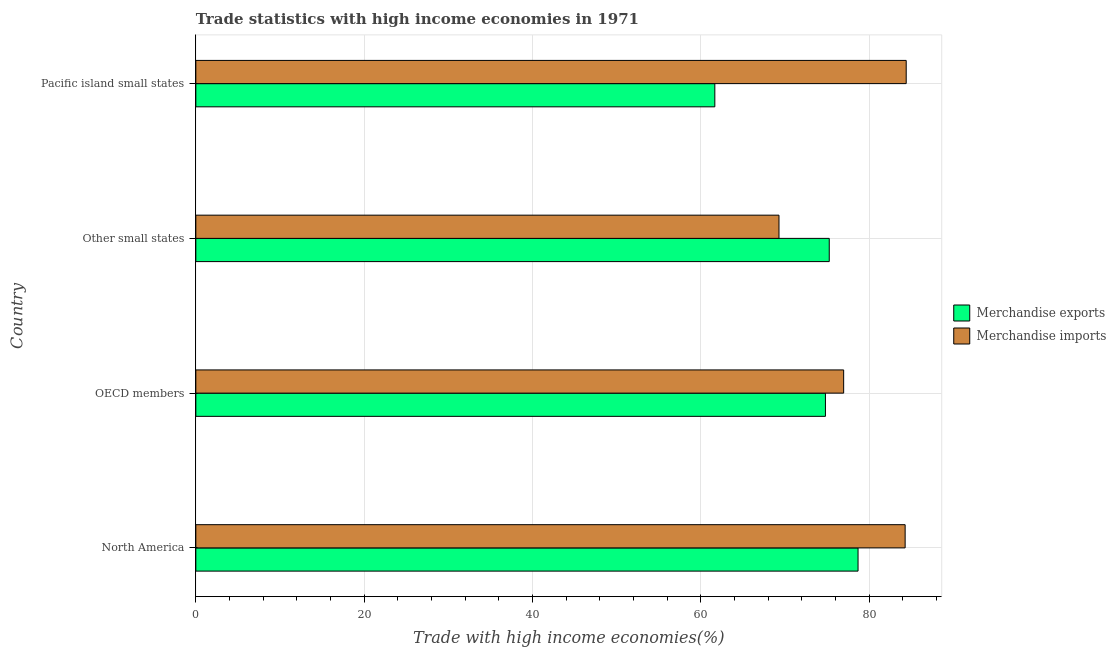How many groups of bars are there?
Provide a short and direct response. 4. Are the number of bars per tick equal to the number of legend labels?
Offer a terse response. Yes. What is the label of the 3rd group of bars from the top?
Make the answer very short. OECD members. What is the merchandise exports in OECD members?
Provide a succinct answer. 74.82. Across all countries, what is the maximum merchandise imports?
Provide a short and direct response. 84.42. Across all countries, what is the minimum merchandise exports?
Make the answer very short. 61.68. In which country was the merchandise imports maximum?
Make the answer very short. Pacific island small states. In which country was the merchandise exports minimum?
Your answer should be very brief. Pacific island small states. What is the total merchandise imports in the graph?
Your answer should be compact. 315. What is the difference between the merchandise imports in North America and that in Pacific island small states?
Give a very brief answer. -0.13. What is the difference between the merchandise exports in Pacific island small states and the merchandise imports in Other small states?
Give a very brief answer. -7.62. What is the average merchandise exports per country?
Your answer should be very brief. 72.62. What is the difference between the merchandise imports and merchandise exports in Pacific island small states?
Provide a short and direct response. 22.74. What is the ratio of the merchandise exports in North America to that in Pacific island small states?
Keep it short and to the point. 1.28. Is the merchandise imports in North America less than that in Other small states?
Keep it short and to the point. No. What is the difference between the highest and the second highest merchandise imports?
Ensure brevity in your answer.  0.13. What is the difference between the highest and the lowest merchandise imports?
Your answer should be very brief. 15.12. What is the difference between two consecutive major ticks on the X-axis?
Make the answer very short. 20. Are the values on the major ticks of X-axis written in scientific E-notation?
Offer a terse response. No. Does the graph contain any zero values?
Your response must be concise. No. What is the title of the graph?
Your answer should be compact. Trade statistics with high income economies in 1971. What is the label or title of the X-axis?
Make the answer very short. Trade with high income economies(%). What is the Trade with high income economies(%) in Merchandise exports in North America?
Keep it short and to the point. 78.7. What is the Trade with high income economies(%) in Merchandise imports in North America?
Give a very brief answer. 84.29. What is the Trade with high income economies(%) of Merchandise exports in OECD members?
Provide a short and direct response. 74.82. What is the Trade with high income economies(%) of Merchandise imports in OECD members?
Ensure brevity in your answer.  76.99. What is the Trade with high income economies(%) of Merchandise exports in Other small states?
Your answer should be very brief. 75.28. What is the Trade with high income economies(%) in Merchandise imports in Other small states?
Your answer should be very brief. 69.3. What is the Trade with high income economies(%) in Merchandise exports in Pacific island small states?
Your response must be concise. 61.68. What is the Trade with high income economies(%) in Merchandise imports in Pacific island small states?
Offer a very short reply. 84.42. Across all countries, what is the maximum Trade with high income economies(%) of Merchandise exports?
Ensure brevity in your answer.  78.7. Across all countries, what is the maximum Trade with high income economies(%) of Merchandise imports?
Provide a succinct answer. 84.42. Across all countries, what is the minimum Trade with high income economies(%) in Merchandise exports?
Keep it short and to the point. 61.68. Across all countries, what is the minimum Trade with high income economies(%) of Merchandise imports?
Keep it short and to the point. 69.3. What is the total Trade with high income economies(%) of Merchandise exports in the graph?
Give a very brief answer. 290.47. What is the total Trade with high income economies(%) in Merchandise imports in the graph?
Provide a short and direct response. 315. What is the difference between the Trade with high income economies(%) in Merchandise exports in North America and that in OECD members?
Keep it short and to the point. 3.88. What is the difference between the Trade with high income economies(%) of Merchandise imports in North America and that in OECD members?
Keep it short and to the point. 7.31. What is the difference between the Trade with high income economies(%) in Merchandise exports in North America and that in Other small states?
Keep it short and to the point. 3.42. What is the difference between the Trade with high income economies(%) of Merchandise imports in North America and that in Other small states?
Provide a short and direct response. 14.99. What is the difference between the Trade with high income economies(%) in Merchandise exports in North America and that in Pacific island small states?
Offer a very short reply. 17.02. What is the difference between the Trade with high income economies(%) in Merchandise imports in North America and that in Pacific island small states?
Your answer should be compact. -0.13. What is the difference between the Trade with high income economies(%) of Merchandise exports in OECD members and that in Other small states?
Make the answer very short. -0.45. What is the difference between the Trade with high income economies(%) of Merchandise imports in OECD members and that in Other small states?
Make the answer very short. 7.69. What is the difference between the Trade with high income economies(%) in Merchandise exports in OECD members and that in Pacific island small states?
Your answer should be compact. 13.14. What is the difference between the Trade with high income economies(%) of Merchandise imports in OECD members and that in Pacific island small states?
Give a very brief answer. -7.43. What is the difference between the Trade with high income economies(%) of Merchandise exports in Other small states and that in Pacific island small states?
Offer a very short reply. 13.6. What is the difference between the Trade with high income economies(%) in Merchandise imports in Other small states and that in Pacific island small states?
Your response must be concise. -15.12. What is the difference between the Trade with high income economies(%) in Merchandise exports in North America and the Trade with high income economies(%) in Merchandise imports in OECD members?
Provide a short and direct response. 1.71. What is the difference between the Trade with high income economies(%) of Merchandise exports in North America and the Trade with high income economies(%) of Merchandise imports in Other small states?
Your answer should be compact. 9.4. What is the difference between the Trade with high income economies(%) of Merchandise exports in North America and the Trade with high income economies(%) of Merchandise imports in Pacific island small states?
Your response must be concise. -5.72. What is the difference between the Trade with high income economies(%) in Merchandise exports in OECD members and the Trade with high income economies(%) in Merchandise imports in Other small states?
Provide a succinct answer. 5.52. What is the difference between the Trade with high income economies(%) in Merchandise exports in OECD members and the Trade with high income economies(%) in Merchandise imports in Pacific island small states?
Provide a short and direct response. -9.6. What is the difference between the Trade with high income economies(%) of Merchandise exports in Other small states and the Trade with high income economies(%) of Merchandise imports in Pacific island small states?
Your response must be concise. -9.15. What is the average Trade with high income economies(%) in Merchandise exports per country?
Provide a succinct answer. 72.62. What is the average Trade with high income economies(%) in Merchandise imports per country?
Offer a terse response. 78.75. What is the difference between the Trade with high income economies(%) of Merchandise exports and Trade with high income economies(%) of Merchandise imports in North America?
Provide a short and direct response. -5.6. What is the difference between the Trade with high income economies(%) in Merchandise exports and Trade with high income economies(%) in Merchandise imports in OECD members?
Your response must be concise. -2.16. What is the difference between the Trade with high income economies(%) of Merchandise exports and Trade with high income economies(%) of Merchandise imports in Other small states?
Ensure brevity in your answer.  5.97. What is the difference between the Trade with high income economies(%) in Merchandise exports and Trade with high income economies(%) in Merchandise imports in Pacific island small states?
Your response must be concise. -22.74. What is the ratio of the Trade with high income economies(%) of Merchandise exports in North America to that in OECD members?
Provide a short and direct response. 1.05. What is the ratio of the Trade with high income economies(%) in Merchandise imports in North America to that in OECD members?
Your response must be concise. 1.09. What is the ratio of the Trade with high income economies(%) in Merchandise exports in North America to that in Other small states?
Provide a succinct answer. 1.05. What is the ratio of the Trade with high income economies(%) in Merchandise imports in North America to that in Other small states?
Make the answer very short. 1.22. What is the ratio of the Trade with high income economies(%) in Merchandise exports in North America to that in Pacific island small states?
Provide a short and direct response. 1.28. What is the ratio of the Trade with high income economies(%) of Merchandise imports in North America to that in Pacific island small states?
Your answer should be very brief. 1. What is the ratio of the Trade with high income economies(%) of Merchandise imports in OECD members to that in Other small states?
Offer a terse response. 1.11. What is the ratio of the Trade with high income economies(%) in Merchandise exports in OECD members to that in Pacific island small states?
Provide a short and direct response. 1.21. What is the ratio of the Trade with high income economies(%) of Merchandise imports in OECD members to that in Pacific island small states?
Offer a very short reply. 0.91. What is the ratio of the Trade with high income economies(%) of Merchandise exports in Other small states to that in Pacific island small states?
Give a very brief answer. 1.22. What is the ratio of the Trade with high income economies(%) in Merchandise imports in Other small states to that in Pacific island small states?
Make the answer very short. 0.82. What is the difference between the highest and the second highest Trade with high income economies(%) of Merchandise exports?
Give a very brief answer. 3.42. What is the difference between the highest and the second highest Trade with high income economies(%) in Merchandise imports?
Ensure brevity in your answer.  0.13. What is the difference between the highest and the lowest Trade with high income economies(%) in Merchandise exports?
Give a very brief answer. 17.02. What is the difference between the highest and the lowest Trade with high income economies(%) in Merchandise imports?
Your answer should be compact. 15.12. 